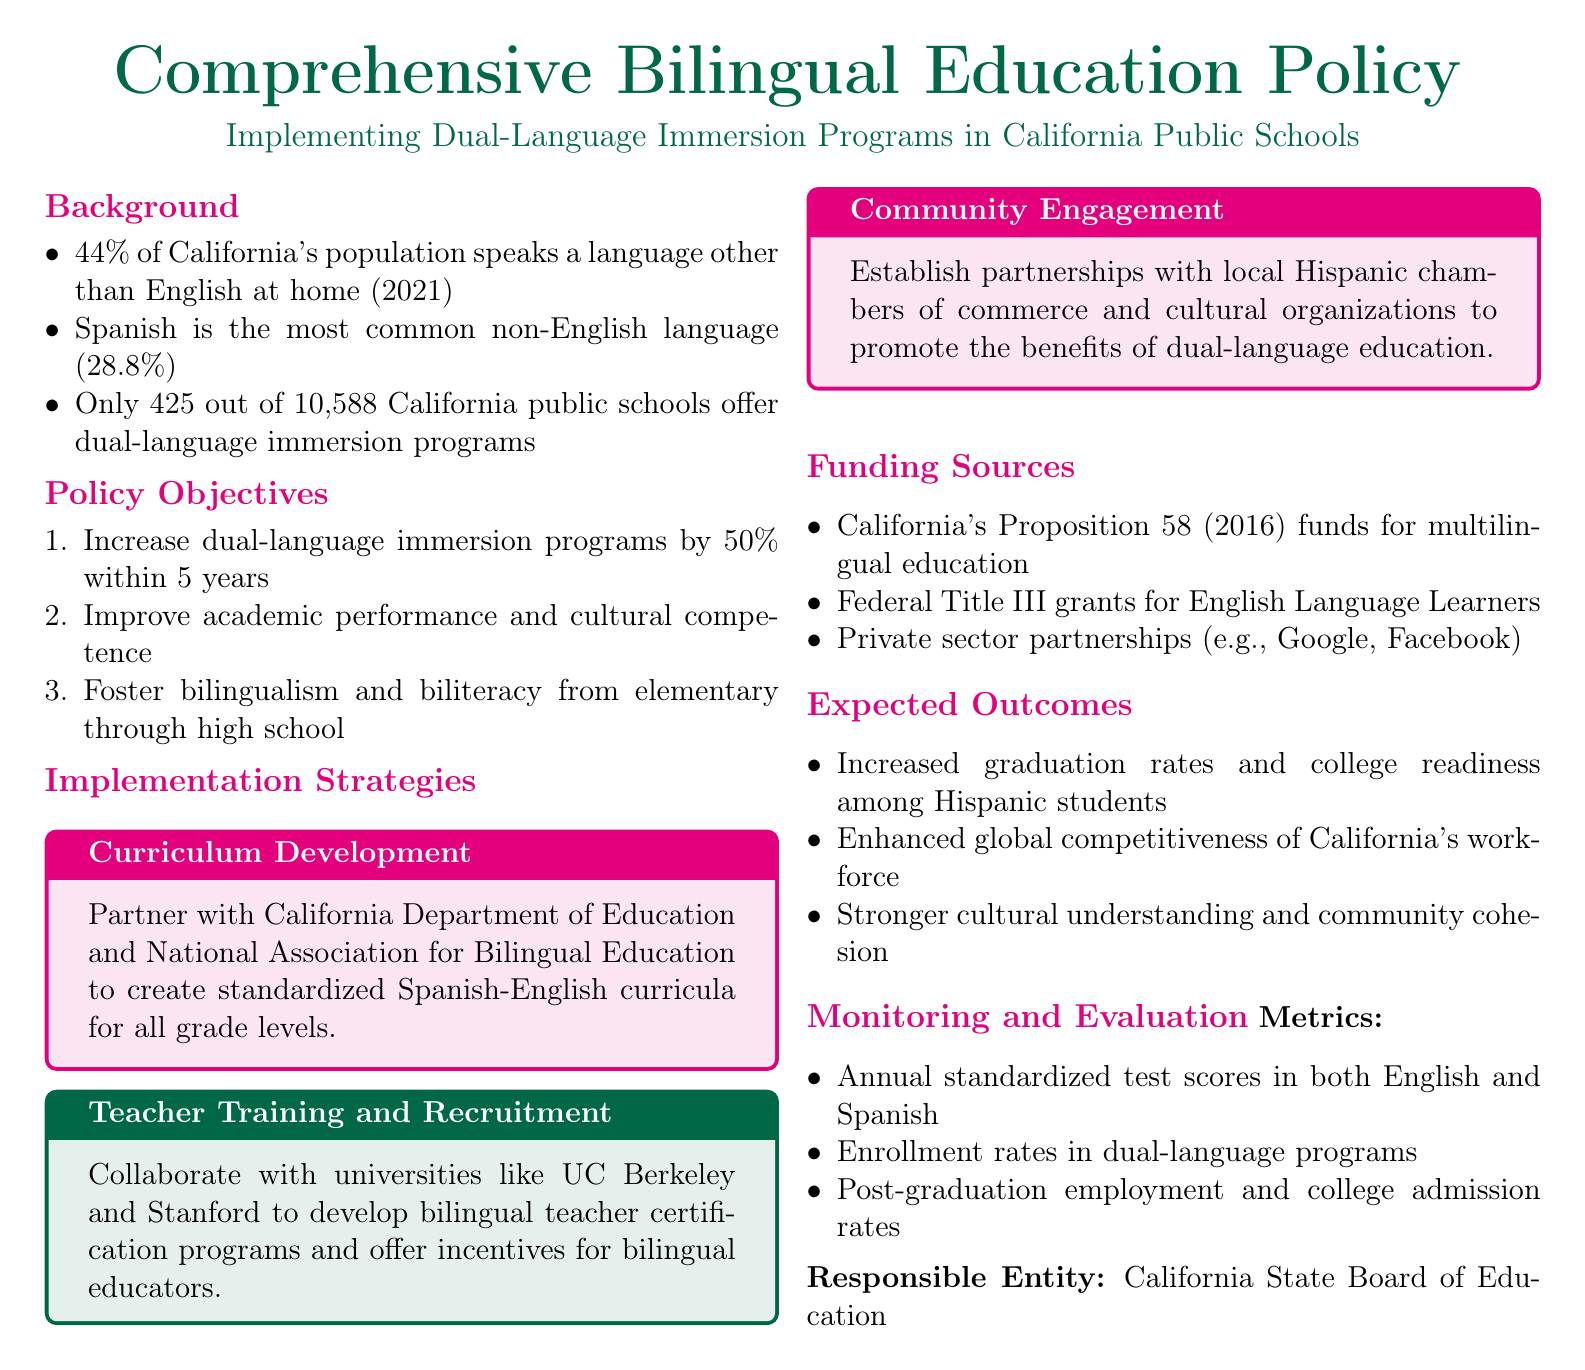What percentage of California's population speaks a language other than English at home? The document states that 44% of California's population speaks a language other than English at home.
Answer: 44% How many California public schools offer dual-language immersion programs? According to the document, only 425 out of 10,588 California public schools offer dual-language immersion programs.
Answer: 425 What is the target increase for dual-language immersion programs within 5 years? The policy aims to increase dual-language immersion programs by 50% within 5 years.
Answer: 50% Which universities are mentioned for teacher training and recruitment? The document mentions UC Berkeley and Stanford for developing bilingual teacher certification programs.
Answer: UC Berkeley and Stanford What funding source is related to multilingual education in California? California's Proposition 58 (2016) provides funding for multilingual education.
Answer: Proposition 58 What is one expected outcome of the bilingual education policy? The document lists increased graduation rates and college readiness among Hispanic students as an expected outcome.
Answer: Increased graduation rates Who is responsible for monitoring and evaluation? The California State Board of Education is identified as the responsible entity for monitoring and evaluation.
Answer: California State Board of Education What is one of the reasons for community engagement? The document states to promote the benefits of dual-language education through partnerships with local organizations.
Answer: Promote benefits of dual-language education What metrics will be used for evaluation? Annual standardized test scores in both English and Spanish will be one of the metrics used for evaluation.
Answer: Annual standardized test scores 